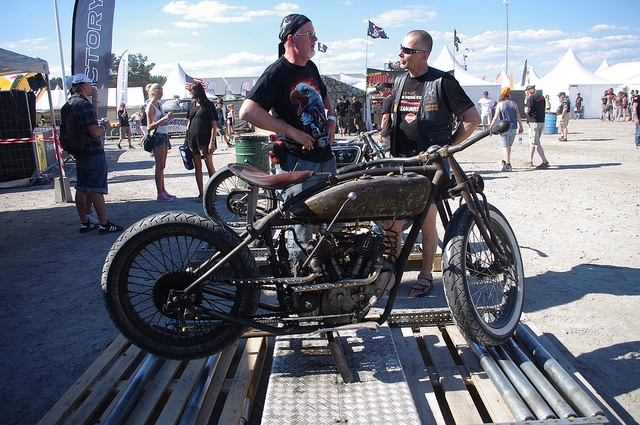Describe the objects in this image and their specific colors. I can see motorcycle in lightblue, black, gray, darkgray, and navy tones, people in lightblue, black, gray, navy, and white tones, people in lightblue, black, gray, maroon, and darkgray tones, people in lightblue, black, navy, gray, and darkblue tones, and people in lightblue, black, gray, lightgray, and darkgray tones in this image. 